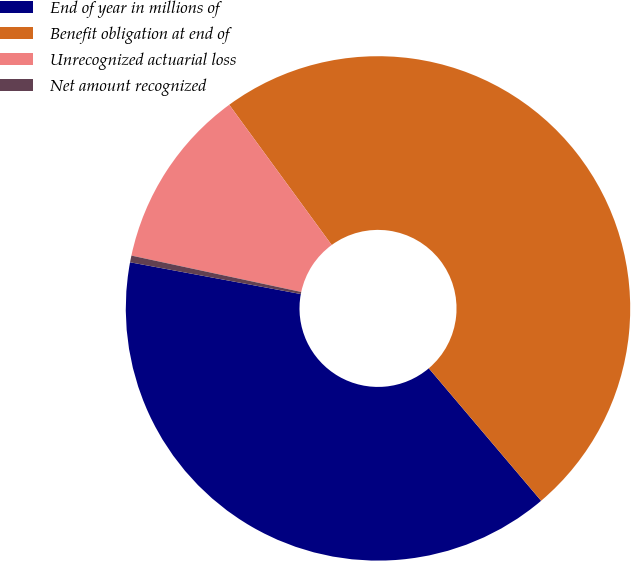Convert chart to OTSL. <chart><loc_0><loc_0><loc_500><loc_500><pie_chart><fcel>End of year in millions of<fcel>Benefit obligation at end of<fcel>Unrecognized actuarial loss<fcel>Net amount recognized<nl><fcel>39.12%<fcel>48.85%<fcel>11.6%<fcel>0.43%<nl></chart> 